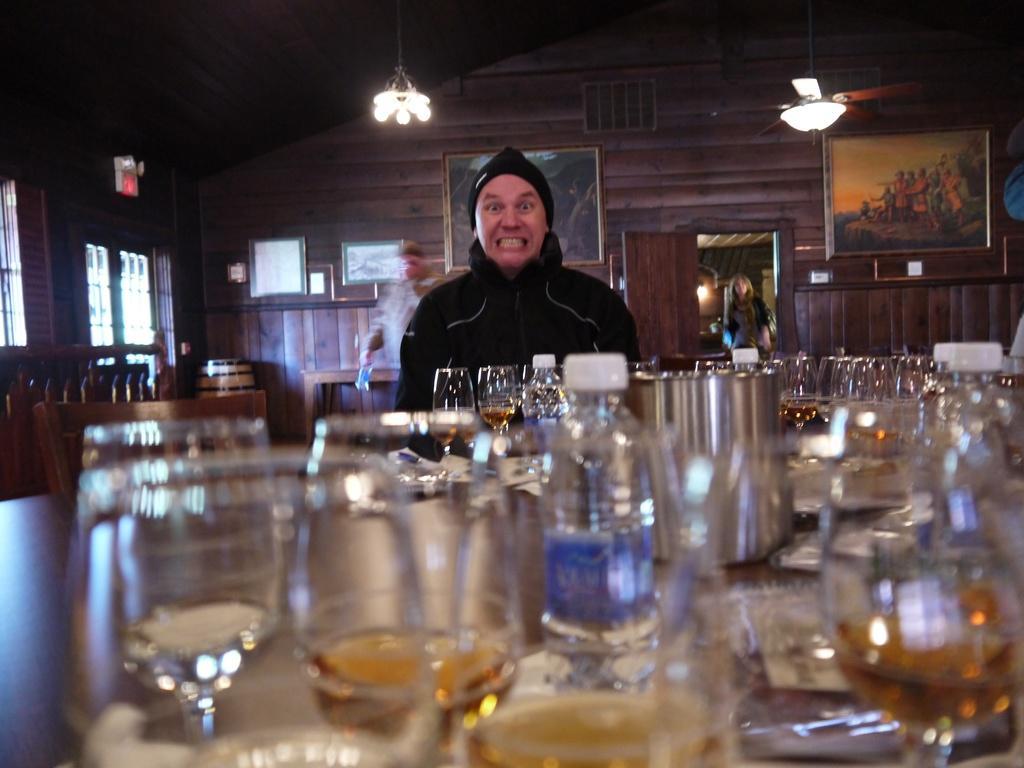In one or two sentences, can you explain what this image depicts? In the image we can see there is a person who is standing and in front of him there is a table on which there are wine glasses and a water bottle and at the back there is a wall on which photo frame and on top there is a ceiling fan. 